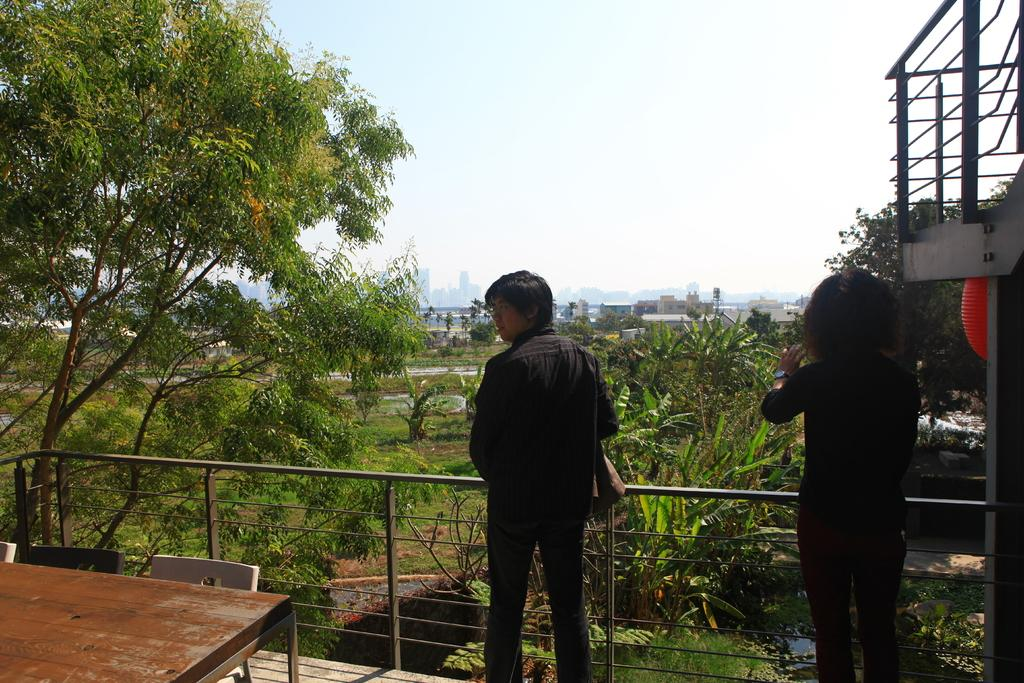What type of furniture is present in the image? There is a table and chairs in the image. What is the setting of the people in the image? The people are in front of a metal fence. What type of natural elements can be seen in the image? There are trees visible in the image. What type of man-made structures can be seen in the image? There are buildings in the image. What type of wire is being used by the school in the image? There is no school or wire present in the image. What type of engine is visible in the image? There is no engine visible in the image. 